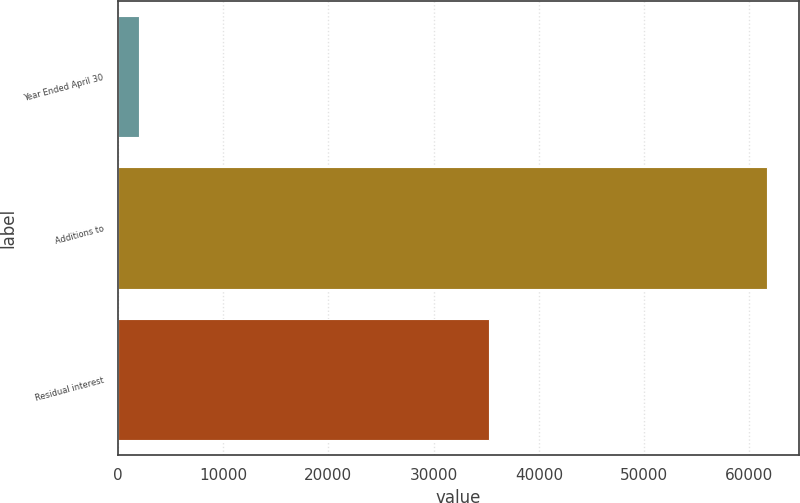Convert chart. <chart><loc_0><loc_0><loc_500><loc_500><bar_chart><fcel>Year Ended April 30<fcel>Additions to<fcel>Residual interest<nl><fcel>2006<fcel>61651<fcel>35274<nl></chart> 